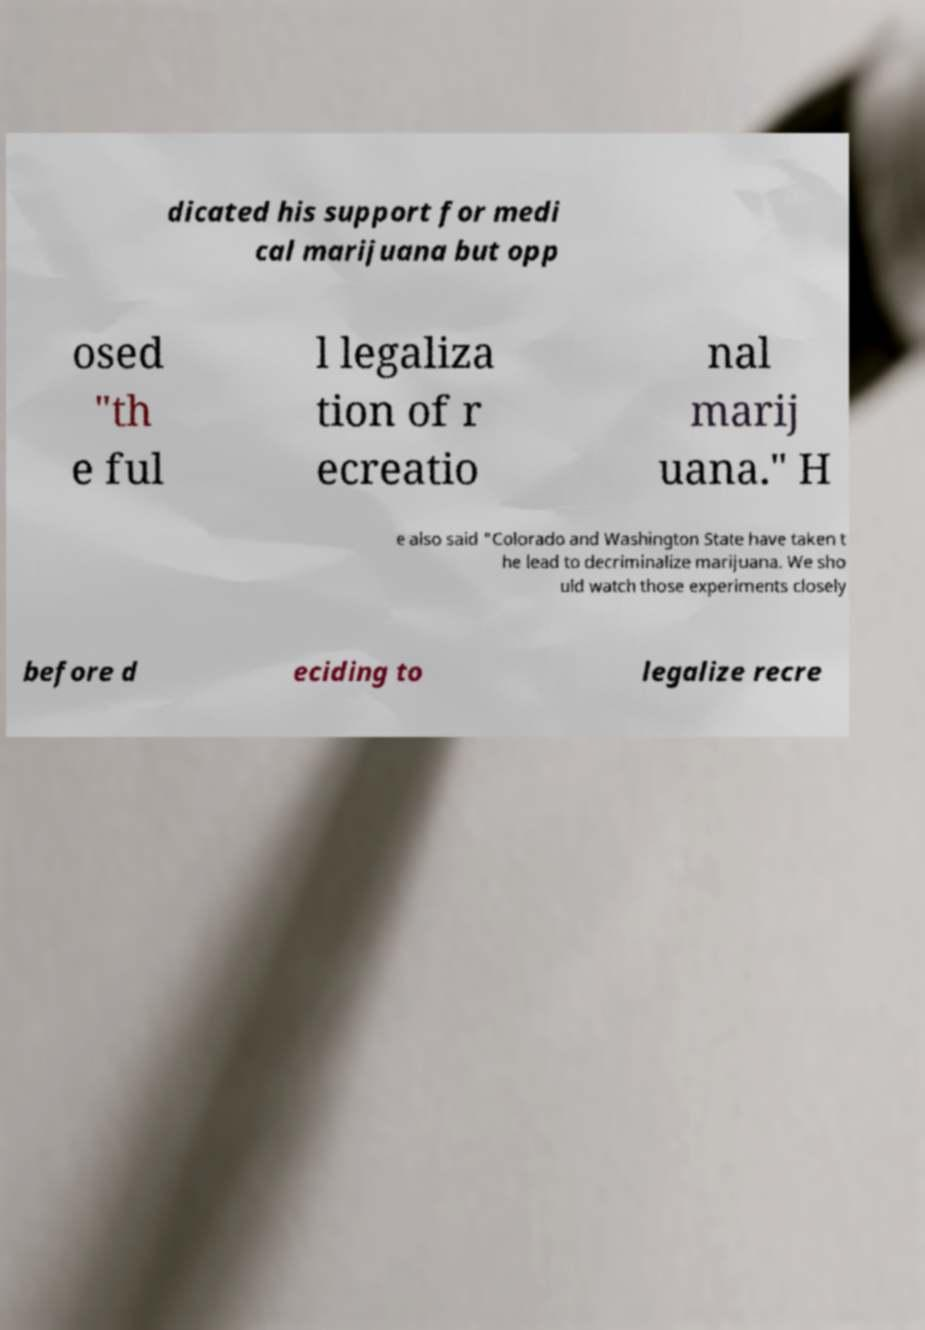I need the written content from this picture converted into text. Can you do that? dicated his support for medi cal marijuana but opp osed "th e ful l legaliza tion of r ecreatio nal marij uana." H e also said "Colorado and Washington State have taken t he lead to decriminalize marijuana. We sho uld watch those experiments closely before d eciding to legalize recre 